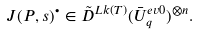<formula> <loc_0><loc_0><loc_500><loc_500>J ( P , s ) ^ { \bullet } \in \tilde { D } ^ { L k ( T ) } ( \bar { U } _ { q } ^ { e v 0 } ) ^ { \otimes n } .</formula> 